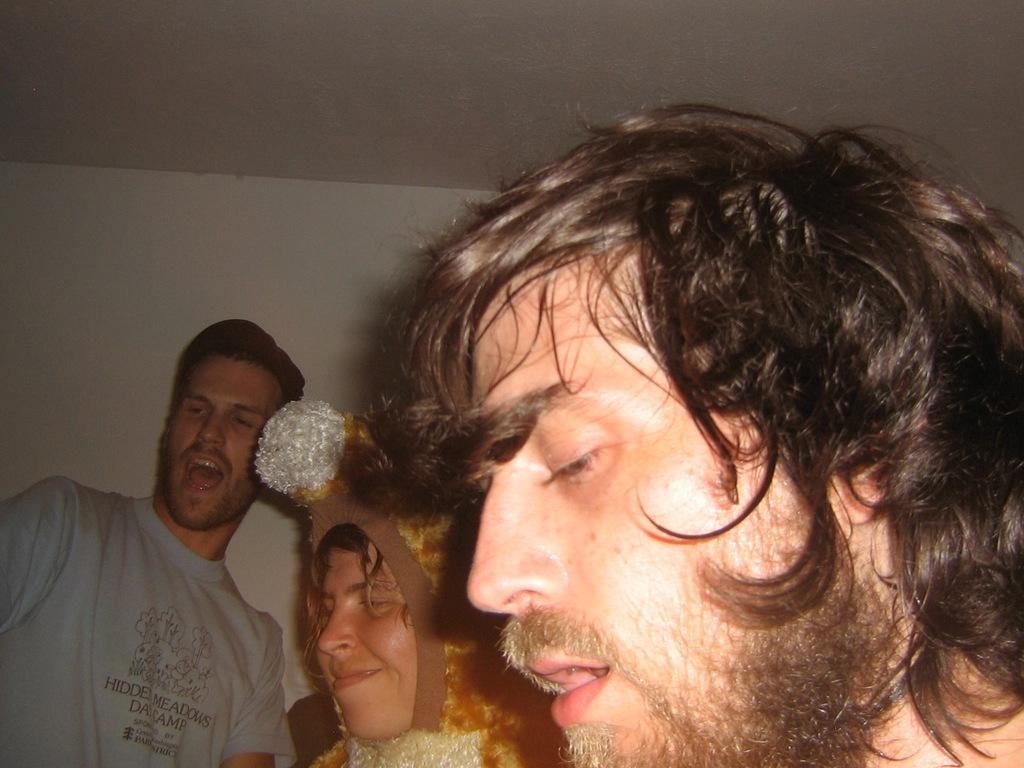Please provide a concise description of this image. Man on the right corner of the picture is singing. Beside him, a woman wearing a cap is smiling and beside her, the man in grey t-shirt is singing the song. Behind them, we see a wall in white color and this picture is clicked inside the room. 